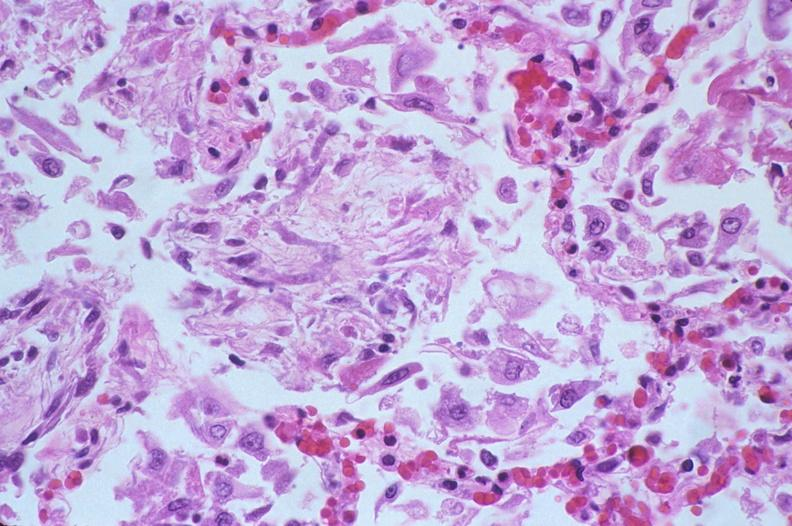does this image show lung, diffuse alveolar damage?
Answer the question using a single word or phrase. Yes 